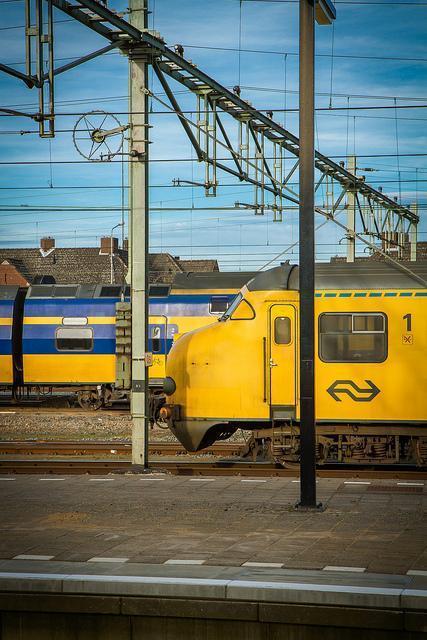How many trains are here?
Give a very brief answer. 2. How many trains are there?
Give a very brief answer. 2. 